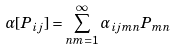Convert formula to latex. <formula><loc_0><loc_0><loc_500><loc_500>\alpha [ P _ { i j } ] = \sum _ { n m = 1 } ^ { \infty } \alpha _ { i j m n } P _ { m n }</formula> 